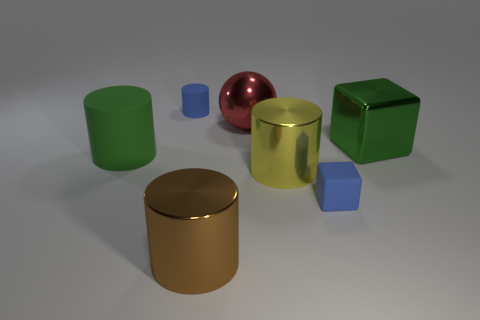There is a yellow shiny thing; does it have the same shape as the rubber object behind the big rubber cylinder? Yes, the yellow shiny object, which appears to be a metallic sphere, shares the same shape as the rubber object positioned behind the large rubber cylinder, both being spherical. 